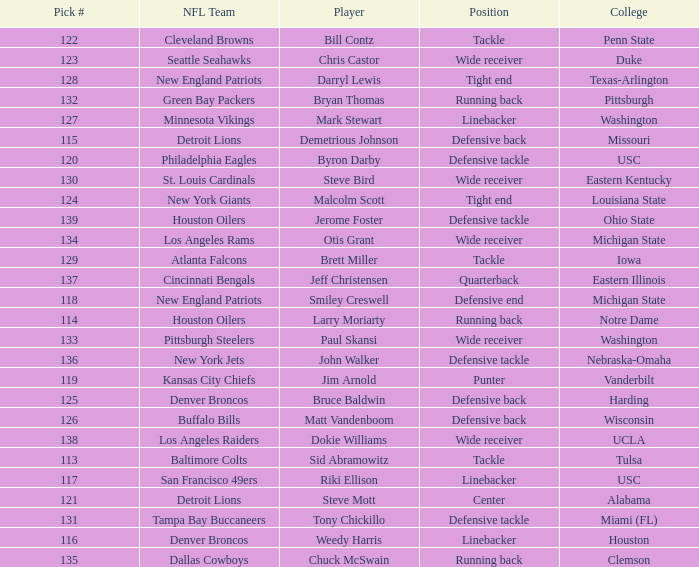What is the highest pick number the los angeles raiders got? 138.0. 